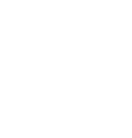Convert code to text. <code><loc_0><loc_0><loc_500><loc_500><_SQL_>  </code> 